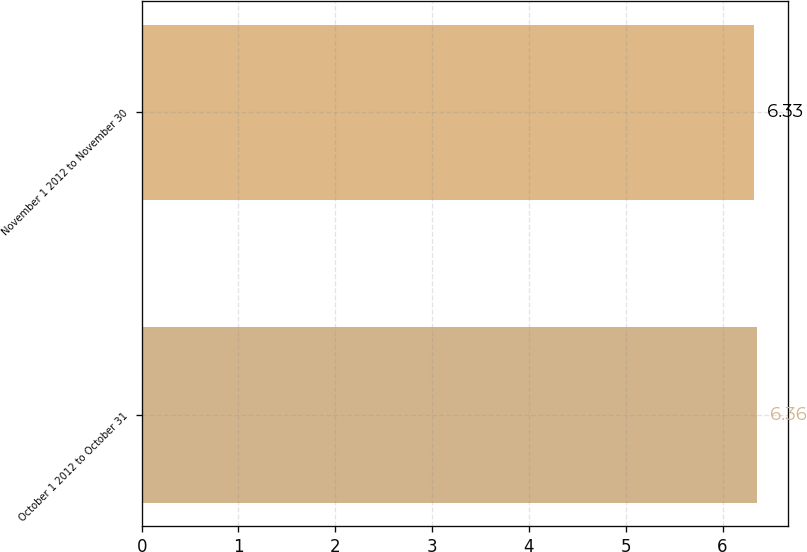Convert chart. <chart><loc_0><loc_0><loc_500><loc_500><bar_chart><fcel>October 1 2012 to October 31<fcel>November 1 2012 to November 30<nl><fcel>6.36<fcel>6.33<nl></chart> 